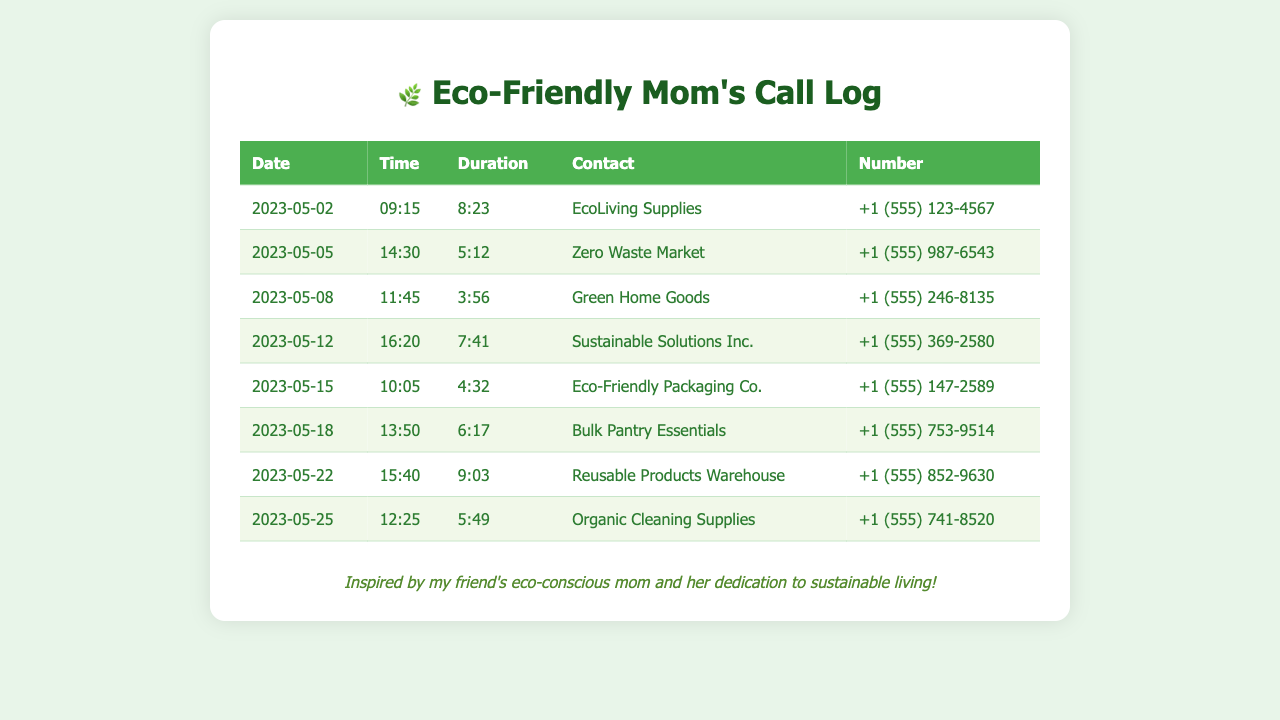What is the name of the first supplier contacted? The first supplier in the call log is listed under the "Contact" column for the date 2023-05-02.
Answer: EcoLiving Supplies What date was the call made to Zero Waste Market? The date of the call made to Zero Waste Market is found in the same row as its name in the table.
Answer: 2023-05-05 How long was the call to Sustainable Solutions Inc.? The duration of the call is listed in the "Duration" column for the entry corresponding to Sustainable Solutions Inc.
Answer: 7:41 Which contact had the longest call duration? The longest call duration can be found by comparing the "Duration" values across all entries.
Answer: Reusable Products Warehouse How many calls were made in total? The total number of calls can be counted by the number of rows in the table.
Answer: 8 Which supplier specializes in organic cleaning products? The supplier specializing in organic cleaning products is indicated in the call log with the corresponding contact name.
Answer: Organic Cleaning Supplies What time was the call to Bulk Pantry Essentials made? The time of the call can be found in the "Time" column for the entry of Bulk Pantry Essentials.
Answer: 13:50 What is the phone number for Eco-Friendly Packaging Co.? The phone number is listed in the "Number" column directly next to Eco-Friendly Packaging Co.
Answer: +1 (555) 147-2589 